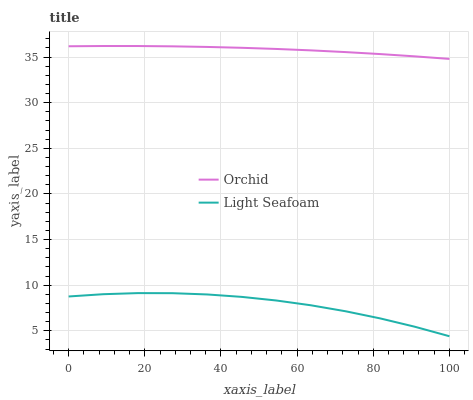Does Light Seafoam have the minimum area under the curve?
Answer yes or no. Yes. Does Orchid have the maximum area under the curve?
Answer yes or no. Yes. Does Orchid have the minimum area under the curve?
Answer yes or no. No. Is Orchid the smoothest?
Answer yes or no. Yes. Is Light Seafoam the roughest?
Answer yes or no. Yes. Is Orchid the roughest?
Answer yes or no. No. Does Light Seafoam have the lowest value?
Answer yes or no. Yes. Does Orchid have the lowest value?
Answer yes or no. No. Does Orchid have the highest value?
Answer yes or no. Yes. Is Light Seafoam less than Orchid?
Answer yes or no. Yes. Is Orchid greater than Light Seafoam?
Answer yes or no. Yes. Does Light Seafoam intersect Orchid?
Answer yes or no. No. 